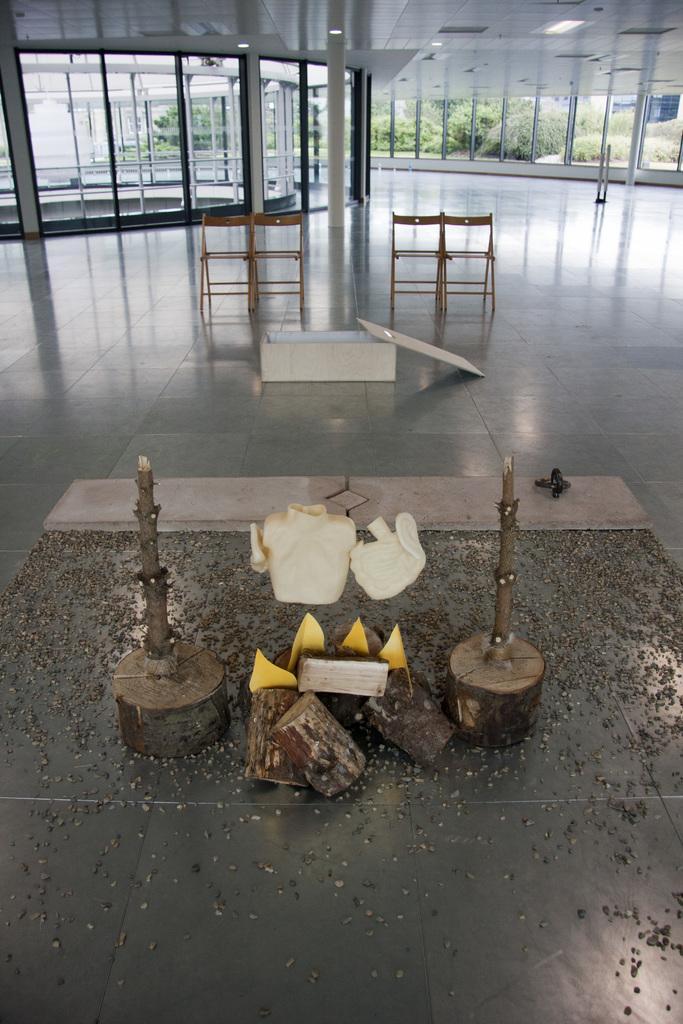Please provide a concise description of this image. In this image we can see some chairs, wooden trunks, there is a box on the floor, there are windows, glass wall, also we can see trees. 